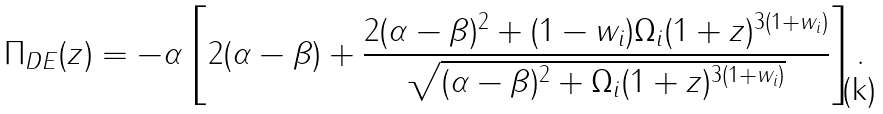<formula> <loc_0><loc_0><loc_500><loc_500>\Pi _ { D E } ( z ) = - \alpha \left [ 2 ( \alpha - \beta ) + \frac { 2 ( \alpha - \beta ) ^ { 2 } + ( 1 - w _ { i } ) \Omega _ { i } ( 1 + z ) ^ { 3 ( 1 + w _ { i } ) } } { \sqrt { ( \alpha - \beta ) ^ { 2 } + \Omega _ { i } ( 1 + z ) ^ { 3 ( 1 + w _ { i } ) } } } \right ] .</formula> 